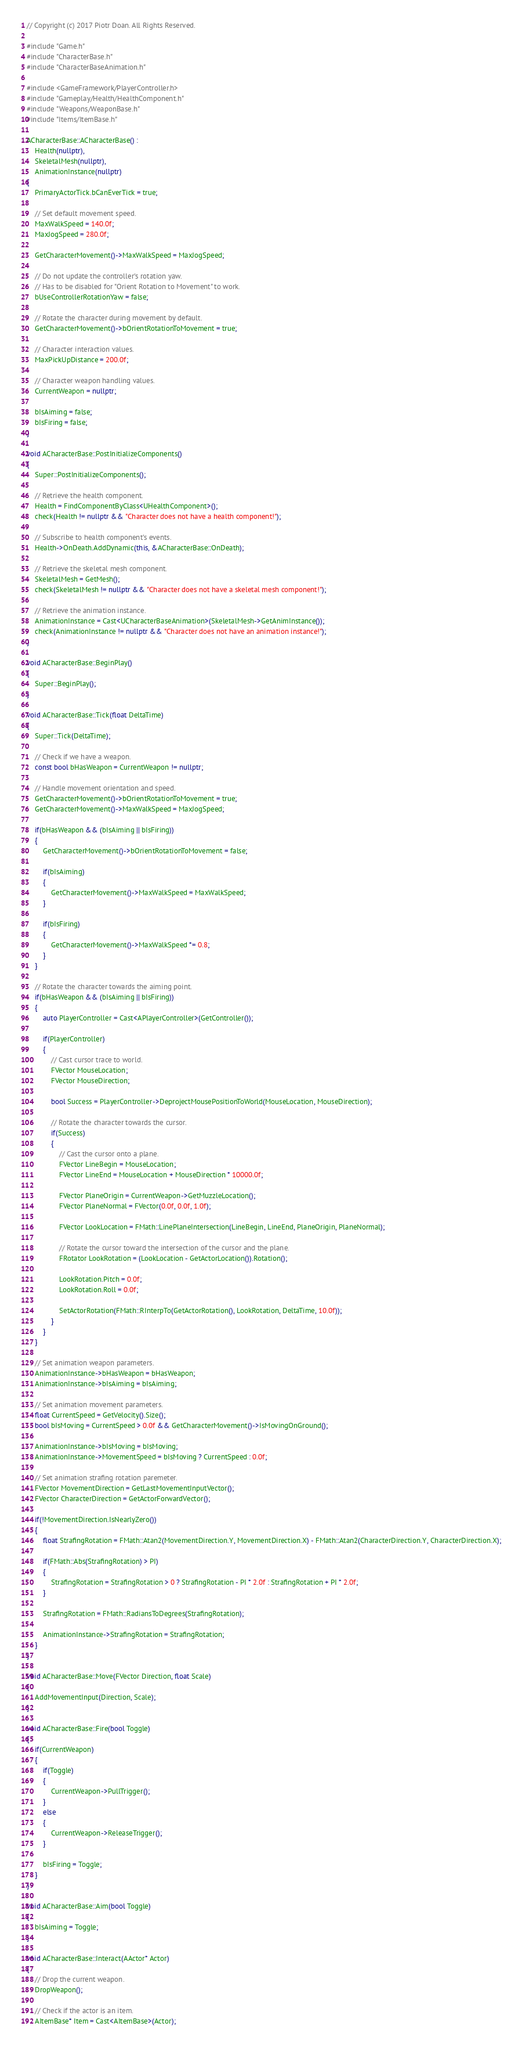<code> <loc_0><loc_0><loc_500><loc_500><_C++_>// Copyright (c) 2017 Piotr Doan. All Rights Reserved.

#include "Game.h"
#include "CharacterBase.h"
#include "CharacterBaseAnimation.h"

#include <GameFramework/PlayerController.h>
#include "Gameplay/Health/HealthComponent.h"
#include "Weapons/WeaponBase.h"
#include "Items/ItemBase.h"

ACharacterBase::ACharacterBase() :
	Health(nullptr),
	SkeletalMesh(nullptr),
	AnimationInstance(nullptr)
{
	PrimaryActorTick.bCanEverTick = true;

	// Set default movement speed.
	MaxWalkSpeed = 140.0f;
	MaxJogSpeed = 280.0f;

	GetCharacterMovement()->MaxWalkSpeed = MaxJogSpeed;

	// Do not update the controller's rotation yaw.
	// Has to be disabled for "Orient Rotation to Movement" to work.
	bUseControllerRotationYaw = false;

	// Rotate the character during movement by default.
	GetCharacterMovement()->bOrientRotationToMovement = true;

	// Character interaction values.
	MaxPickUpDistance = 200.0f;

	// Character weapon handling values.
	CurrentWeapon = nullptr;

	bIsAiming = false;
	bIsFiring = false;
}

void ACharacterBase::PostInitializeComponents()
{
	Super::PostInitializeComponents();

	// Retrieve the health component.
	Health = FindComponentByClass<UHealthComponent>();
	check(Health != nullptr && "Character does not have a health component!");

	// Subscribe to health component's events.
	Health->OnDeath.AddDynamic(this, &ACharacterBase::OnDeath);

	// Retrieve the skeletal mesh component.
	SkeletalMesh = GetMesh();
	check(SkeletalMesh != nullptr && "Character does not have a skeletal mesh component!");

	// Retrieve the animation instance.
	AnimationInstance = Cast<UCharacterBaseAnimation>(SkeletalMesh->GetAnimInstance());
	check(AnimationInstance != nullptr && "Character does not have an animation instance!");
}

void ACharacterBase::BeginPlay()
{
	Super::BeginPlay();
}

void ACharacterBase::Tick(float DeltaTime)
{
	Super::Tick(DeltaTime);

	// Check if we have a weapon.
	const bool bHasWeapon = CurrentWeapon != nullptr;

	// Handle movement orientation and speed.
	GetCharacterMovement()->bOrientRotationToMovement = true;
	GetCharacterMovement()->MaxWalkSpeed = MaxJogSpeed;

	if(bHasWeapon && (bIsAiming || bIsFiring))
	{
		GetCharacterMovement()->bOrientRotationToMovement = false;

		if(bIsAiming)
		{
			GetCharacterMovement()->MaxWalkSpeed = MaxWalkSpeed;
		}

		if(bIsFiring)
		{
			GetCharacterMovement()->MaxWalkSpeed *= 0.8;
		}
	}

	// Rotate the character towards the aiming point.
	if(bHasWeapon && (bIsAiming || bIsFiring))
	{
		auto PlayerController = Cast<APlayerController>(GetController());

		if(PlayerController)
		{
			// Cast cursor trace to world.
			FVector MouseLocation;
			FVector MouseDirection;

			bool Success = PlayerController->DeprojectMousePositionToWorld(MouseLocation, MouseDirection);

			// Rotate the character towards the cursor.
			if(Success)
			{
				// Cast the cursor onto a plane.
				FVector LineBegin = MouseLocation;
				FVector LineEnd = MouseLocation + MouseDirection * 10000.0f;

				FVector PlaneOrigin = CurrentWeapon->GetMuzzleLocation();
				FVector PlaneNormal = FVector(0.0f, 0.0f, 1.0f);

				FVector LookLocation = FMath::LinePlaneIntersection(LineBegin, LineEnd, PlaneOrigin, PlaneNormal);

				// Rotate the cursor toward the intersection of the cursor and the plane.
				FRotator LookRotation = (LookLocation - GetActorLocation()).Rotation();

				LookRotation.Pitch = 0.0f;
				LookRotation.Roll = 0.0f;

				SetActorRotation(FMath::RInterpTo(GetActorRotation(), LookRotation, DeltaTime, 10.0f));
			}
		}
	}

	// Set animation weapon parameters.
	AnimationInstance->bHasWeapon = bHasWeapon;
	AnimationInstance->bIsAiming = bIsAiming;

	// Set animation movement parameters.
	float CurrentSpeed = GetVelocity().Size();
	bool bIsMoving = CurrentSpeed > 0.0f && GetCharacterMovement()->IsMovingOnGround();

	AnimationInstance->bIsMoving = bIsMoving;
	AnimationInstance->MovementSpeed = bIsMoving ? CurrentSpeed : 0.0f;

	// Set animation strafing rotation paremeter.
	FVector MovementDirection = GetLastMovementInputVector();
	FVector CharacterDirection = GetActorForwardVector();

	if(!MovementDirection.IsNearlyZero())
	{
		float StrafingRotation = FMath::Atan2(MovementDirection.Y, MovementDirection.X) - FMath::Atan2(CharacterDirection.Y, CharacterDirection.X);

		if(FMath::Abs(StrafingRotation) > PI)
		{
			StrafingRotation = StrafingRotation > 0 ? StrafingRotation - PI * 2.0f : StrafingRotation + PI * 2.0f;
		}

		StrafingRotation = FMath::RadiansToDegrees(StrafingRotation);

		AnimationInstance->StrafingRotation = StrafingRotation;
	}
}

void ACharacterBase::Move(FVector Direction, float Scale)
{
	AddMovementInput(Direction, Scale);
}

void ACharacterBase::Fire(bool Toggle)
{
	if(CurrentWeapon)
	{
		if(Toggle)
		{
			CurrentWeapon->PullTrigger();
		}
		else
		{
			CurrentWeapon->ReleaseTrigger();
		}
		
		bIsFiring = Toggle;
	}
}

void ACharacterBase::Aim(bool Toggle)
{
	bIsAiming = Toggle;
}

void ACharacterBase::Interact(AActor* Actor)
{
	// Drop the current weapon.
	DropWeapon();

	// Check if the actor is an item.
	AItemBase* Item = Cast<AItemBase>(Actor);
</code> 